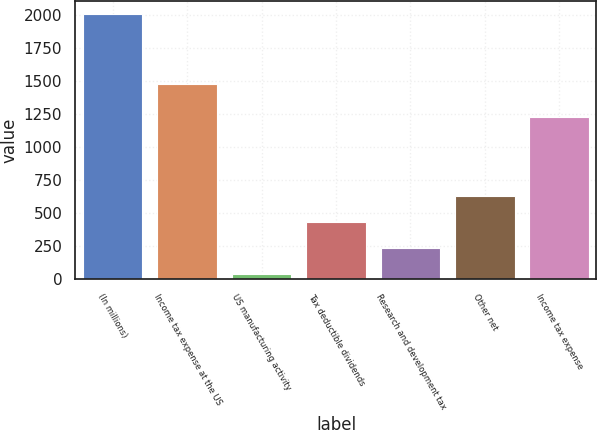Convert chart to OTSL. <chart><loc_0><loc_0><loc_500><loc_500><bar_chart><fcel>(In millions)<fcel>Income tax expense at the US<fcel>US manufacturing activity<fcel>Tax deductible dividends<fcel>Research and development tax<fcel>Other net<fcel>Income tax expense<nl><fcel>2009<fcel>1481<fcel>39<fcel>433<fcel>236<fcel>630<fcel>1231<nl></chart> 